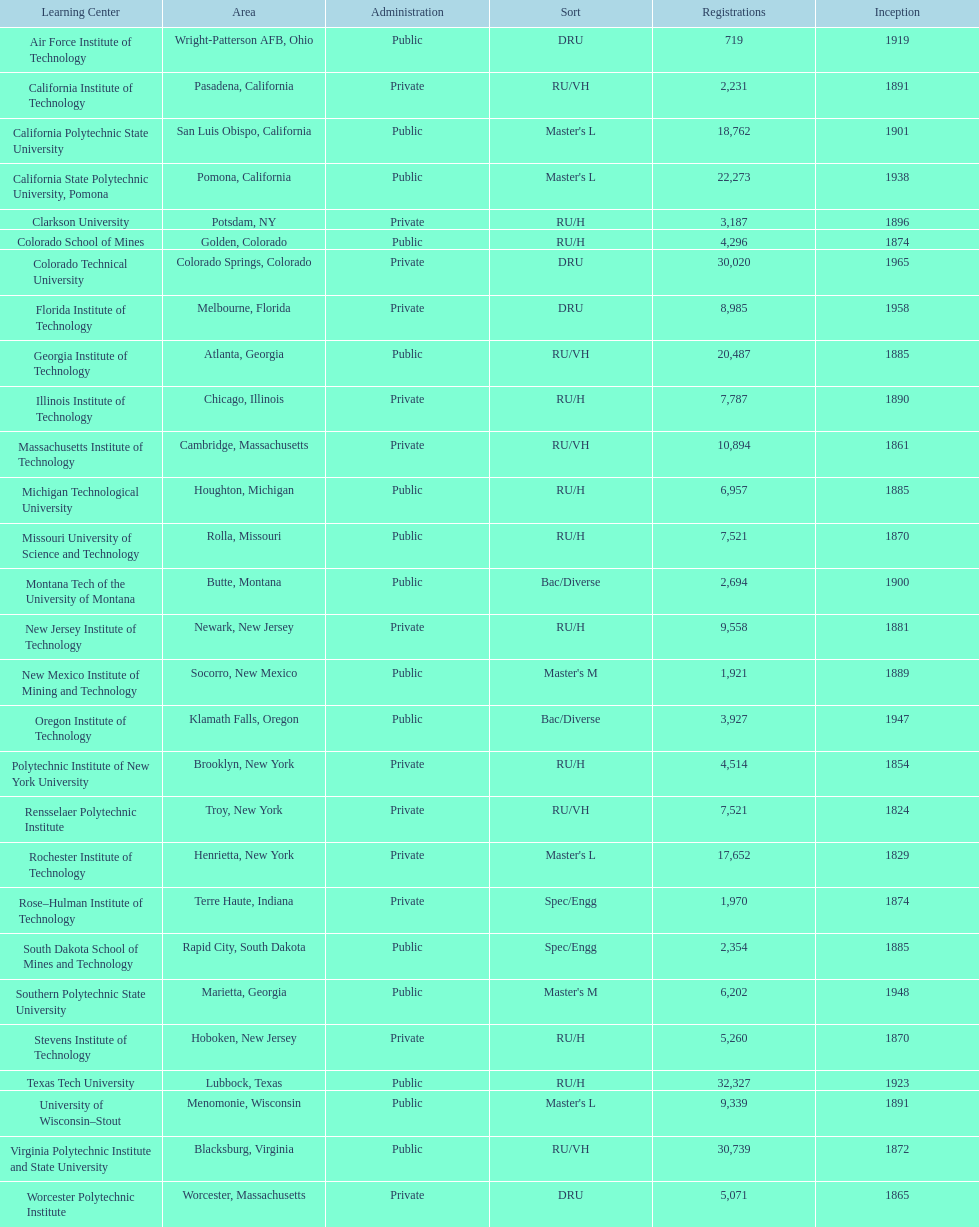What is the difference in enrollment between the top 2 schools listed in the table? 1512. 